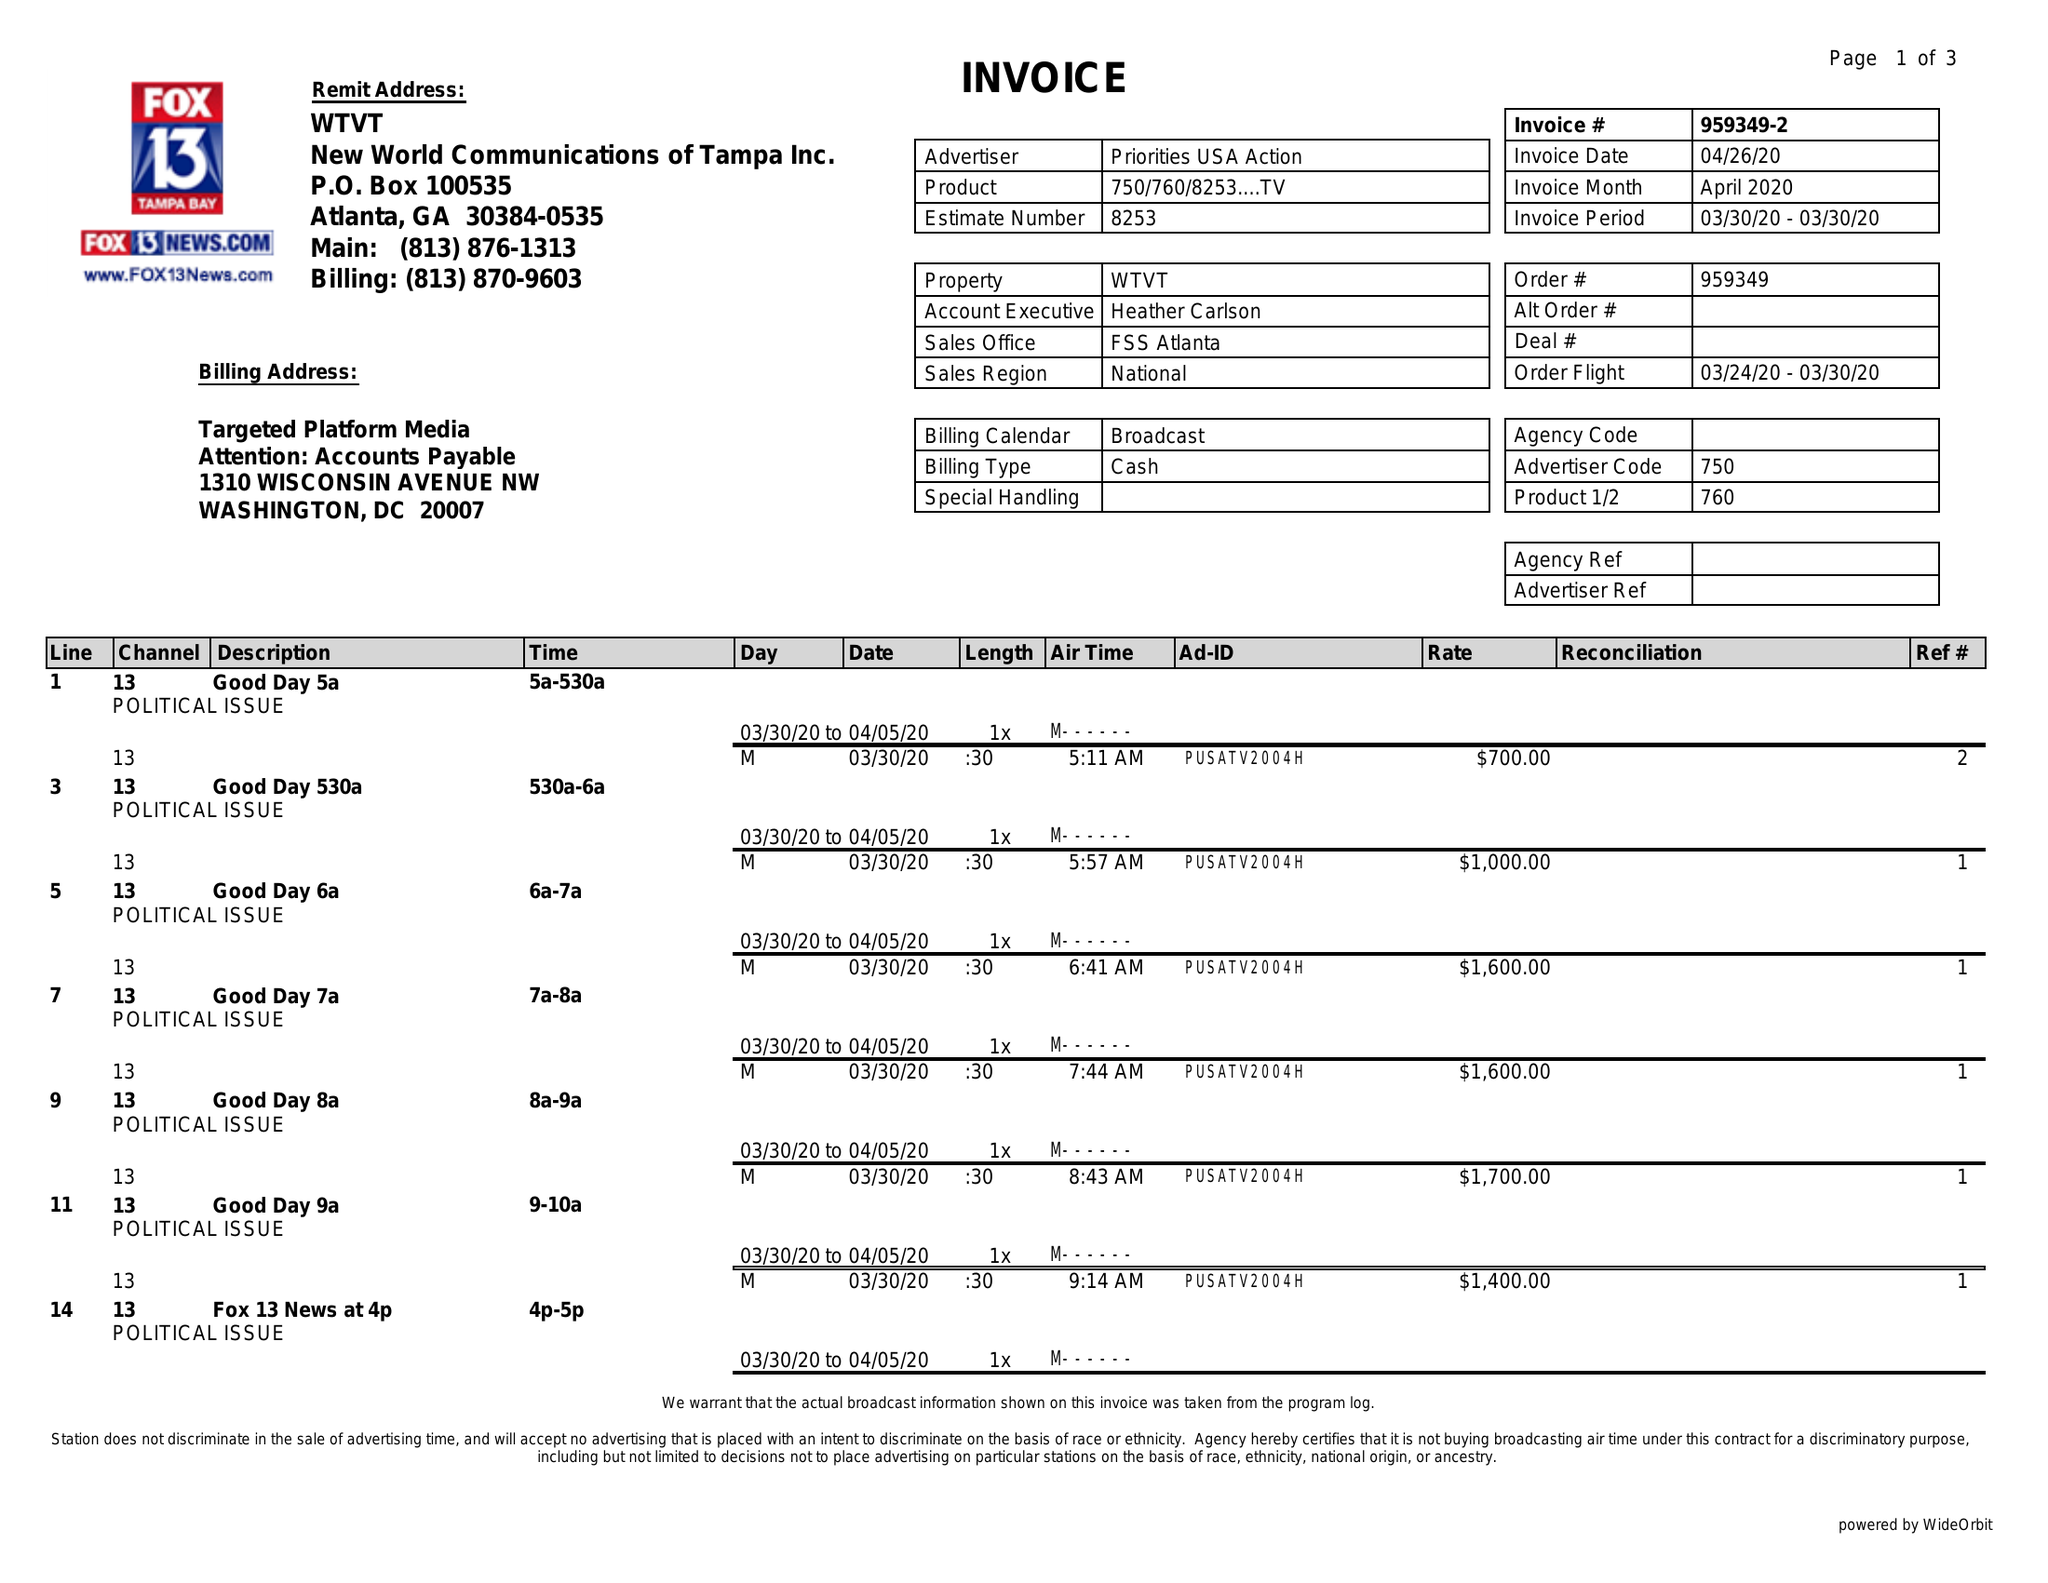What is the value for the contract_num?
Answer the question using a single word or phrase. 959349 